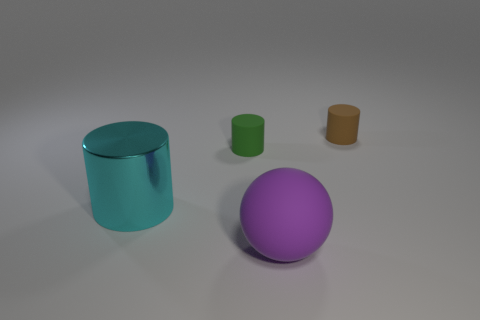Subtract all small green cylinders. How many cylinders are left? 2 Subtract all green cylinders. How many cylinders are left? 2 Subtract 2 cylinders. How many cylinders are left? 1 Add 4 tiny green rubber cylinders. How many objects exist? 8 Subtract all cylinders. How many objects are left? 1 Add 4 big cyan metallic cylinders. How many big cyan metallic cylinders are left? 5 Add 2 small yellow balls. How many small yellow balls exist? 2 Subtract 0 green cubes. How many objects are left? 4 Subtract all cyan cylinders. Subtract all yellow blocks. How many cylinders are left? 2 Subtract all red balls. How many red cylinders are left? 0 